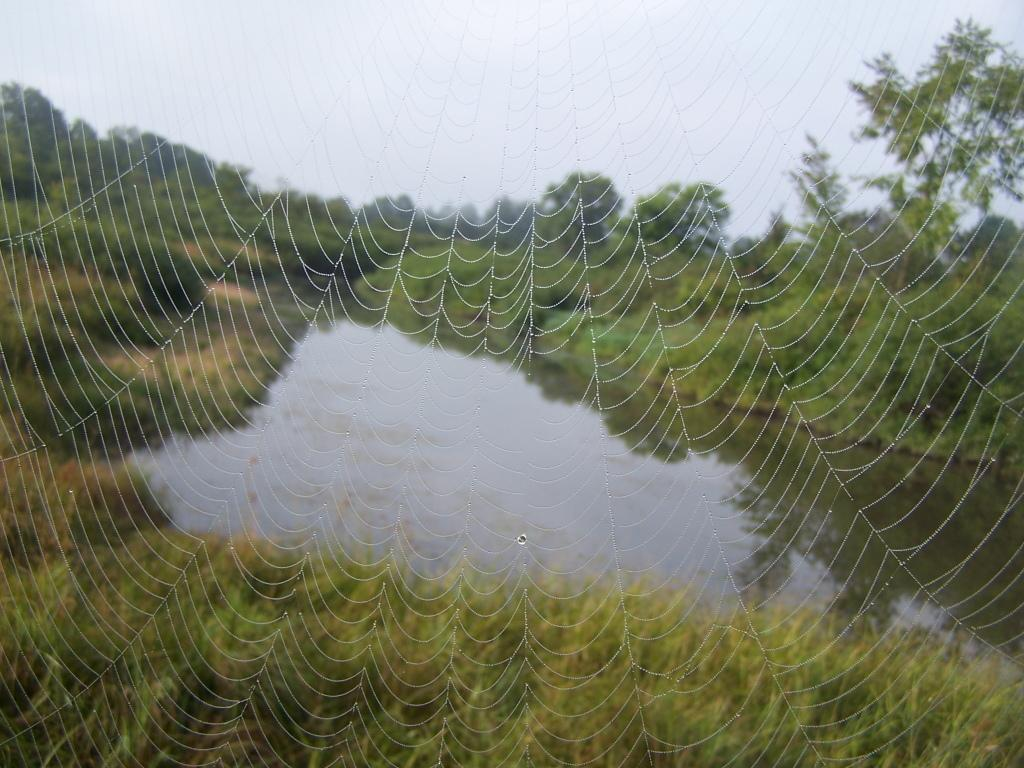What is located in the front of the image? There is a spider web in the front of the image. What can be seen in the background of the image? There are plants, trees, and water visible in the background of the image. What is visible at the top of the image? The sky is visible at the top of the image. What type of caption is written below the spider web in the image? There is no caption written below the spider web in the image. How many kittens are playing with the tank in the image? There are no kittens or tanks present in the image. 